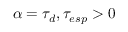Convert formula to latex. <formula><loc_0><loc_0><loc_500><loc_500>\alpha = \tau _ { d } , \tau _ { e s p } > 0</formula> 